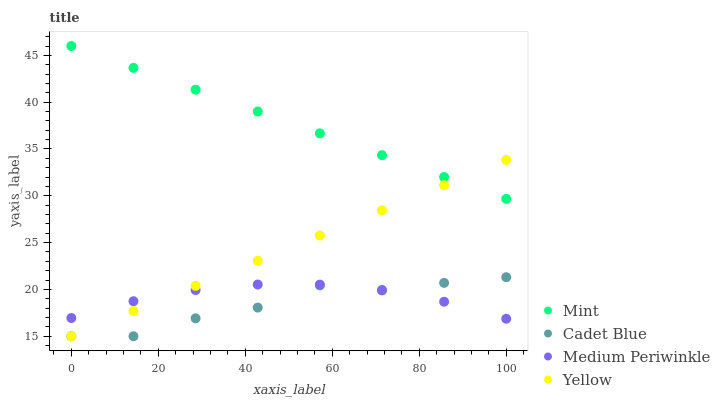Does Cadet Blue have the minimum area under the curve?
Answer yes or no. Yes. Does Mint have the maximum area under the curve?
Answer yes or no. Yes. Does Mint have the minimum area under the curve?
Answer yes or no. No. Does Cadet Blue have the maximum area under the curve?
Answer yes or no. No. Is Yellow the smoothest?
Answer yes or no. Yes. Is Cadet Blue the roughest?
Answer yes or no. Yes. Is Mint the smoothest?
Answer yes or no. No. Is Mint the roughest?
Answer yes or no. No. Does Cadet Blue have the lowest value?
Answer yes or no. Yes. Does Mint have the lowest value?
Answer yes or no. No. Does Mint have the highest value?
Answer yes or no. Yes. Does Cadet Blue have the highest value?
Answer yes or no. No. Is Cadet Blue less than Mint?
Answer yes or no. Yes. Is Mint greater than Cadet Blue?
Answer yes or no. Yes. Does Yellow intersect Medium Periwinkle?
Answer yes or no. Yes. Is Yellow less than Medium Periwinkle?
Answer yes or no. No. Is Yellow greater than Medium Periwinkle?
Answer yes or no. No. Does Cadet Blue intersect Mint?
Answer yes or no. No. 